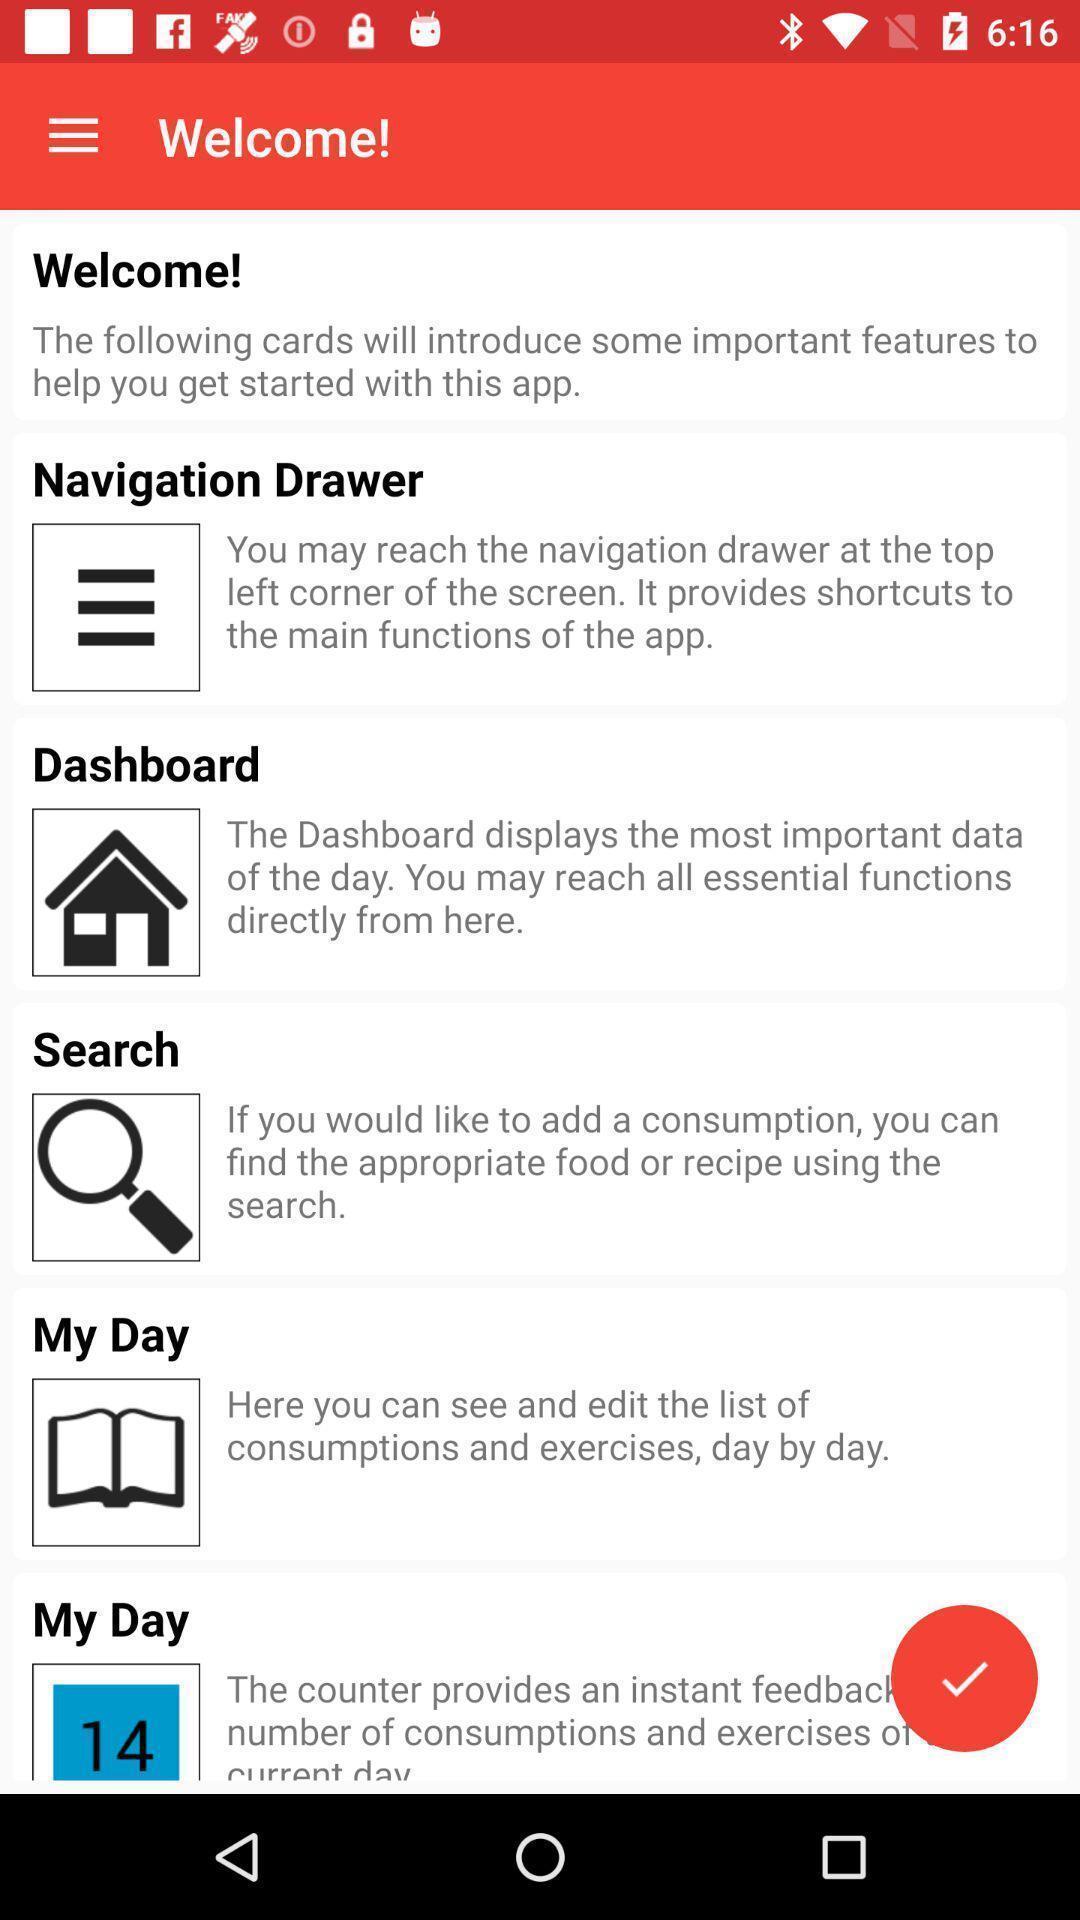What is the overall content of this screenshot? Welcome page. 